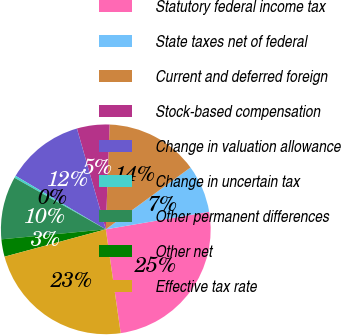Convert chart to OTSL. <chart><loc_0><loc_0><loc_500><loc_500><pie_chart><fcel>Statutory federal income tax<fcel>State taxes net of federal<fcel>Current and deferred foreign<fcel>Stock-based compensation<fcel>Change in valuation allowance<fcel>Change in uncertain tax<fcel>Other permanent differences<fcel>Other net<fcel>Effective tax rate<nl><fcel>25.41%<fcel>7.36%<fcel>14.38%<fcel>5.02%<fcel>12.04%<fcel>0.34%<fcel>9.7%<fcel>2.68%<fcel>23.07%<nl></chart> 